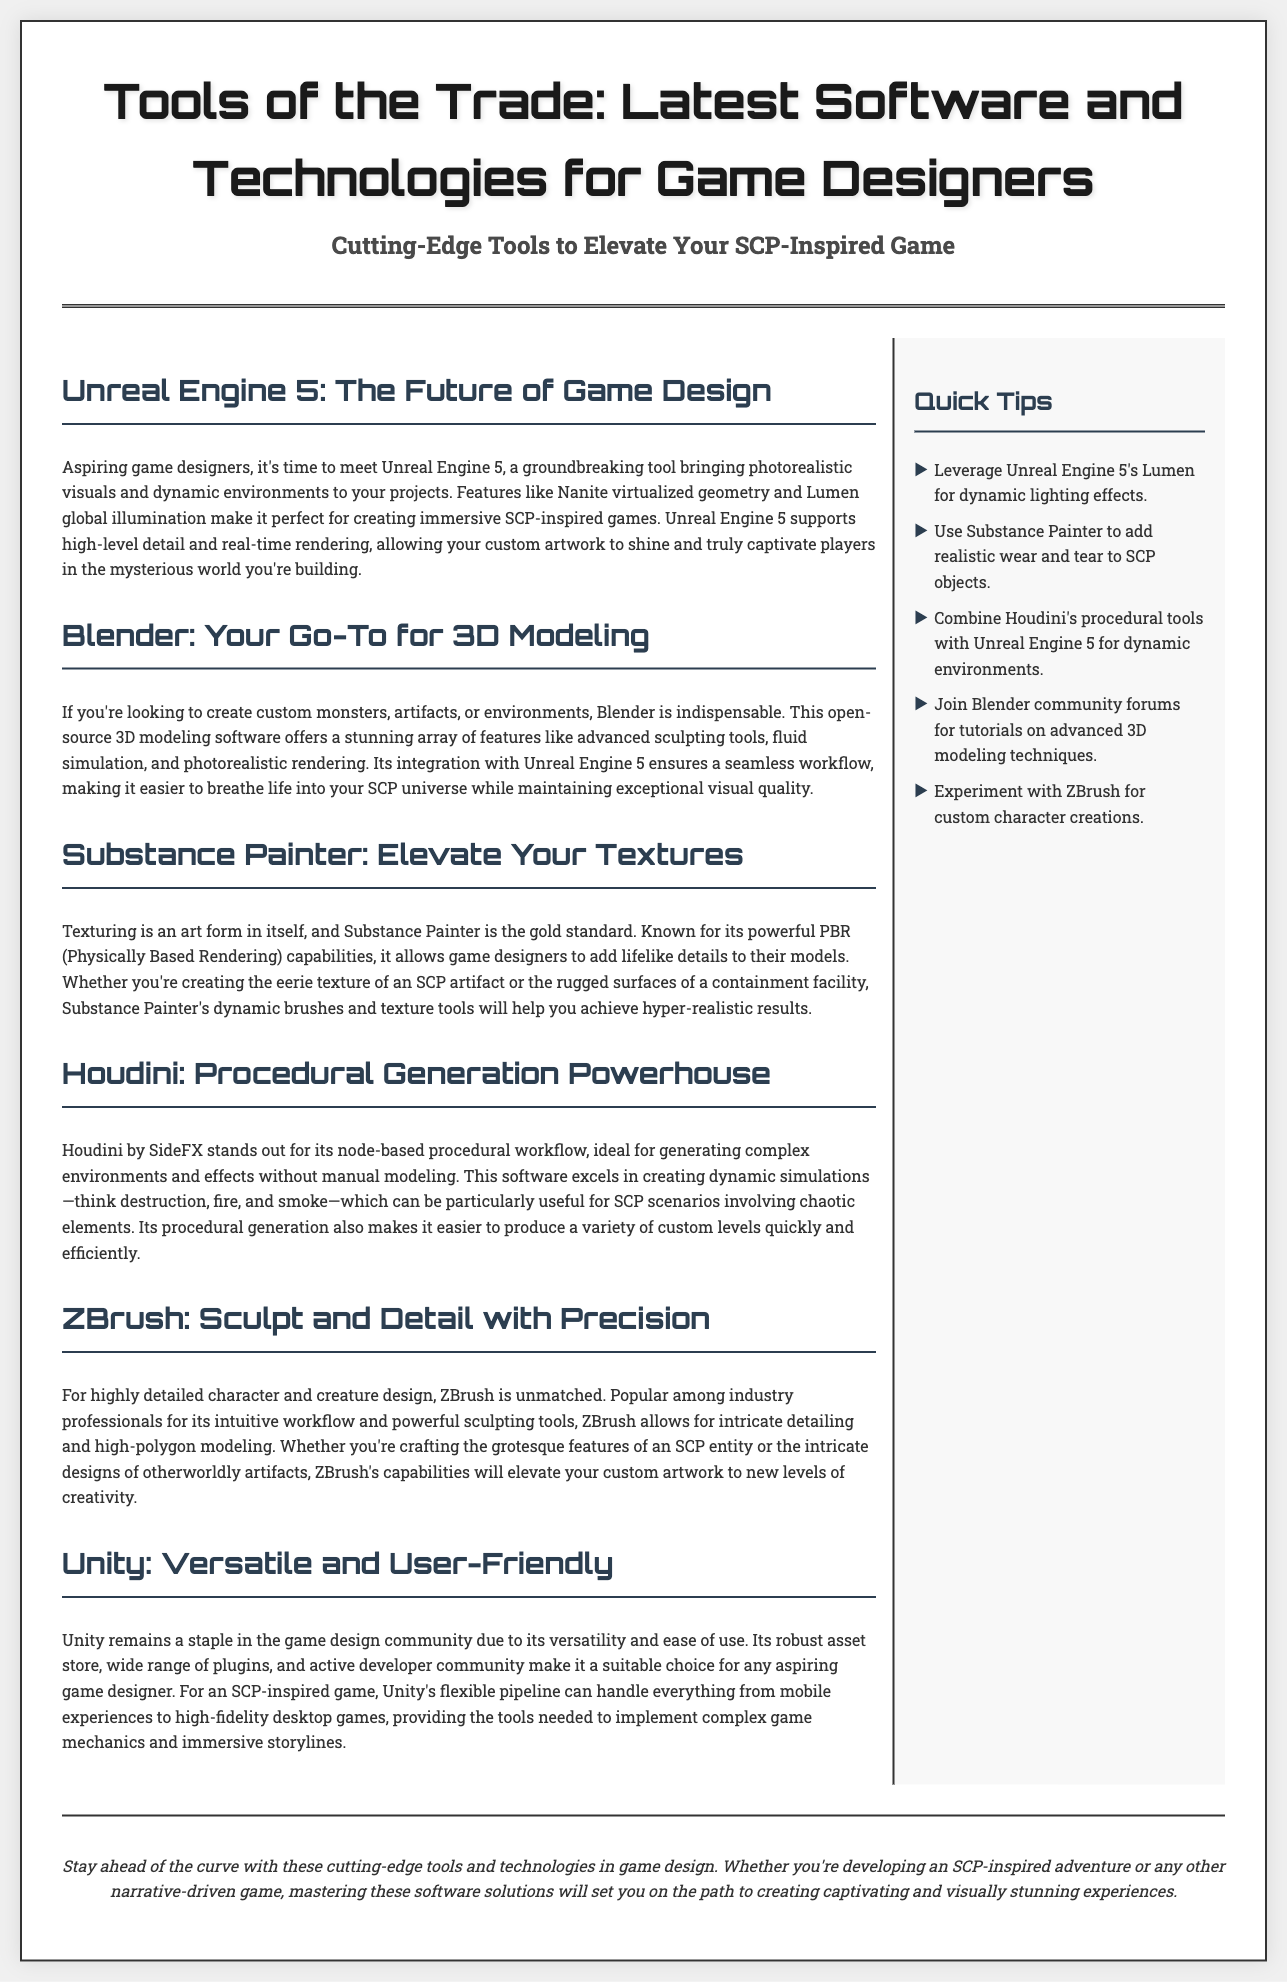What is the main topic of the newspaper? The main topic is indicated in the title of the newspaper, which highlights the tools and technologies for game designers.
Answer: Tools of the Trade: Latest Software and Technologies for Game Designers Which software is referred to as a "groundbreaking tool"? The document describes Unreal Engine 5 as a groundbreaking tool that brings photorealistic visuals to projects.
Answer: Unreal Engine 5 What is Blender primarily used for? The text states that Blender is indispensable for creating custom monsters, artifacts, or environments.
Answer: 3D modeling What feature of Substance Painter is emphasized? The document highlights Substance Painter's powerful PBR (Physically Based Rendering) capabilities in texturing.
Answer: PBR capabilities Which software is identified as a "procedural generation powerhouse"? The document explicitly mentions Houdini by SideFX as a procedural generation powerhouse.
Answer: Houdini What percentage of the content is dedicated to main articles versus sidebar tips? The content structure indicates that the main content takes up 70% and the sidebar takes up 25%.
Answer: 70% main content, 25% sidebar How many quick tips are listed in the sidebar? The document lists five quick tips within the sidebar section.
Answer: Five Which game engine is noted for its versatility and user-friendliness? Unity is specifically mentioned as a staple in the game design community due to its versatility and ease of use.
Answer: Unity What is said to be the focus of the last sentence in the footer? The last sentence in the footer mentions staying ahead of the curve with cutting-edge tools and technologies.
Answer: Staying ahead of the curve 